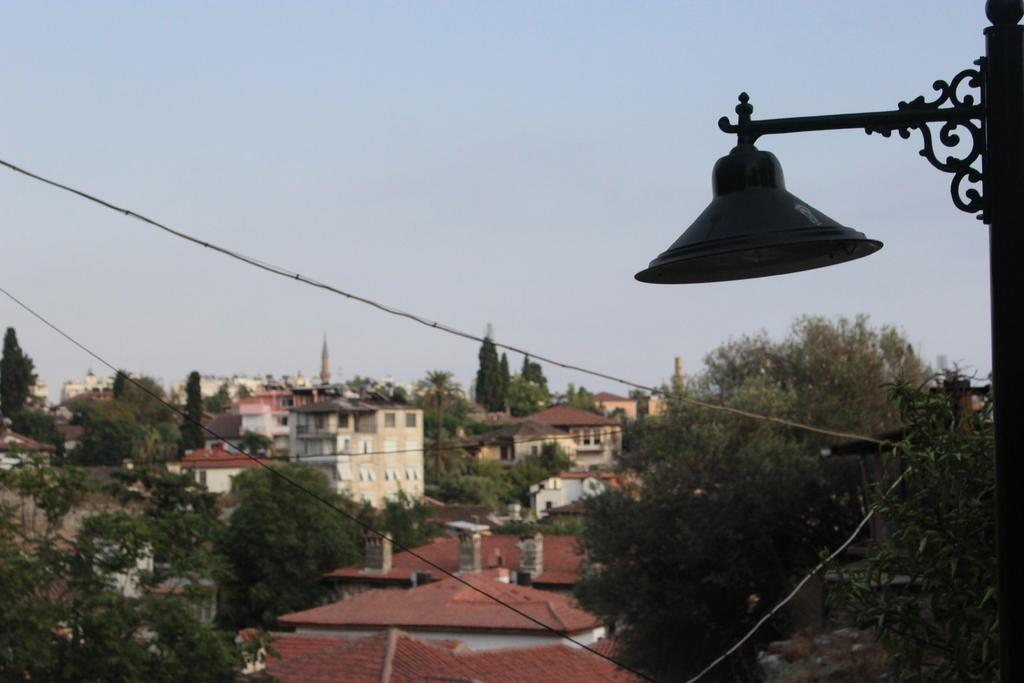What is attached to the pole in the image? There is a light attached to the pole in the image. What else can be seen on the pole? The pole has cables. What can be seen in the background of the image? There are trees, buildings, and the sky visible in the background of the image. Can you see any cakes on the pole in the image? There are no cakes present on the pole or in the image. 